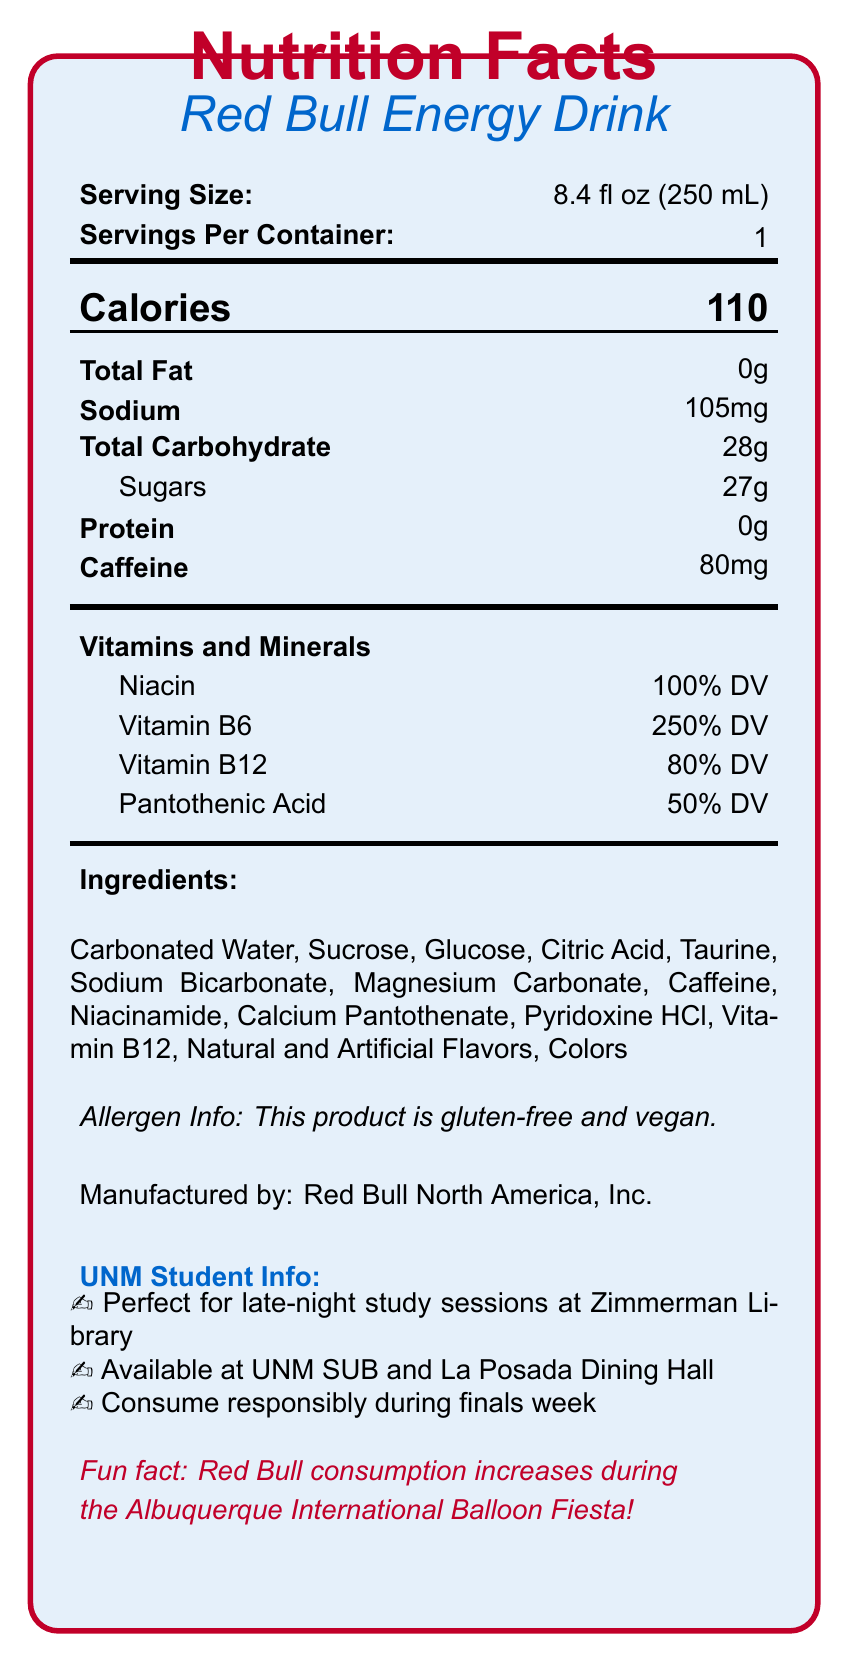what is the serving size of Red Bull Energy Drink? The document specifies the serving size as "8.4 fl oz (250 mL)" under the Serving information section.
Answer: 8.4 fl oz (250 mL) how many calories are in one serving of Red Bull Energy Drink? The document lists "Calories 110" in the calories row under its section.
Answer: 110 how much caffeine is there in a can of Red Bull? The document states "Caffeine 80mg" under the nutrient section.
Answer: 80mg name one vitamin found in Red Bull Energy Drink and its daily value percentage. The document lists Vitamin B6 at "250% DV" under the Vitamins and Minerals section.
Answer: Vitamin B6, 250% DV is Red Bull Energy Drink gluten-free and vegan? The allergen information section states that the product is gluten-free and vegan.
Answer: Yes what are the main ingredients in Red Bull Energy Drink? A. Water, Sucrose, Sodium Bicarbonate B. Carbonated Water, Sucrose, Magnesium Carbonate C. Carbonated Water, Sucrose, Glucose, Caffeine The ingredients section lists these as "Carbonated Water, Sucrose, Glucose, Caffeine," plus additional items.
Answer: C. Carbonated Water, Sucrose, Glucose, Caffeine what is the main purpose of consuming Red Bull Energy Drink for students? A. For exercise recovery B. To stay awake during study sessions C. To reduce stress The Student Info section mentions it is "Perfect for late-night study sessions at Zimmerman Library."
Answer: B. To stay awake during study sessions should students consume Red Bull excessively during finals week? The document warns, "Consume responsibly during finals week."
Answer: No is Red Bull available on the UNM campus? The document states that Red Bull is "Available at UNM SUB and La Posada Dining Hall."
Answer: Yes summarize the main nutritional information provided for Red Bull Energy Drink. This summary covers all the essential nutritional information provided in the document, including the amounts and daily values of calories, sodium, carbohydrates, caffeine, and vitamins.
Answer: Red Bull Energy Drink contains 110 calories per 8.4 fl oz serving, with no fat or protein, 105mg of sodium, 28g of total carbohydrates, and 80mg of caffeine. It also provides significant daily values of various vitamins such as Niacin, Vitamin B6, Vitamin B12, and Pantothenic Acid. what type of study does Red Bull specifically mention aiding in the document? The document does not specify a type of study; it only mentions "late-night study sessions."
Answer: Not enough information what is the manufacturer of Red Bull Energy Drink? The document states "Manufactured by: Red Bull North America, Inc." near the bottom.
Answer: Red Bull North America, Inc. 